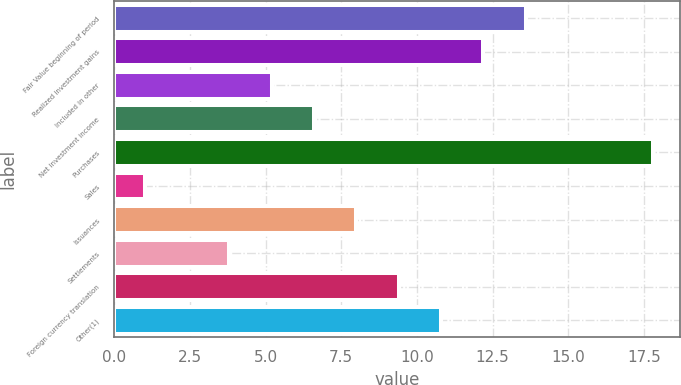Convert chart. <chart><loc_0><loc_0><loc_500><loc_500><bar_chart><fcel>Fair Value beginning of period<fcel>Realized investment gains<fcel>Included in other<fcel>Net investment income<fcel>Purchases<fcel>Sales<fcel>Issuances<fcel>Settlements<fcel>Foreign currency translation<fcel>Other(1)<nl><fcel>13.6<fcel>12.2<fcel>5.2<fcel>6.6<fcel>17.8<fcel>1<fcel>8<fcel>3.8<fcel>9.4<fcel>10.8<nl></chart> 